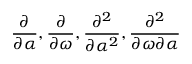<formula> <loc_0><loc_0><loc_500><loc_500>\frac { \partial } { \partial \alpha } , \frac { \partial } { \partial \omega } , \frac { \partial ^ { 2 } } { \partial \alpha ^ { 2 } } , \frac { \partial ^ { 2 } } { \partial \omega \partial \alpha }</formula> 